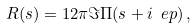<formula> <loc_0><loc_0><loc_500><loc_500>R ( s ) = 1 2 \pi \Im \Pi ( s + i \ e p ) \, ,</formula> 